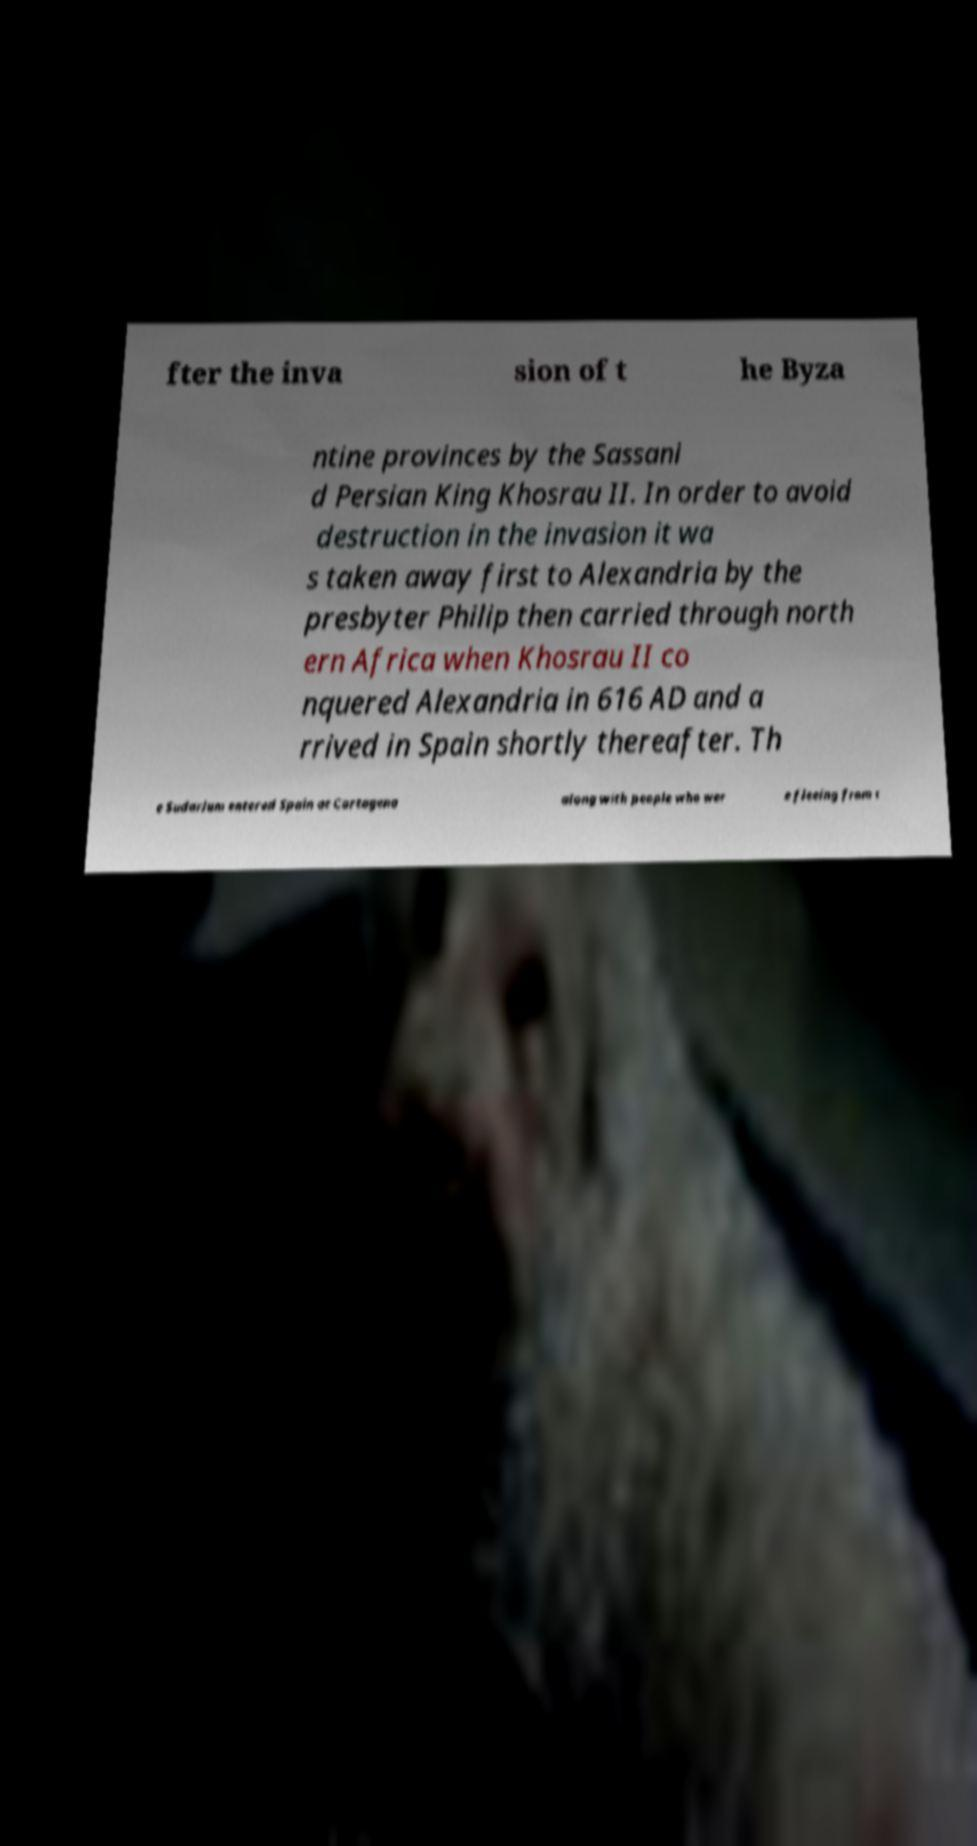For documentation purposes, I need the text within this image transcribed. Could you provide that? fter the inva sion of t he Byza ntine provinces by the Sassani d Persian King Khosrau II. In order to avoid destruction in the invasion it wa s taken away first to Alexandria by the presbyter Philip then carried through north ern Africa when Khosrau II co nquered Alexandria in 616 AD and a rrived in Spain shortly thereafter. Th e Sudarium entered Spain at Cartagena along with people who wer e fleeing from t 